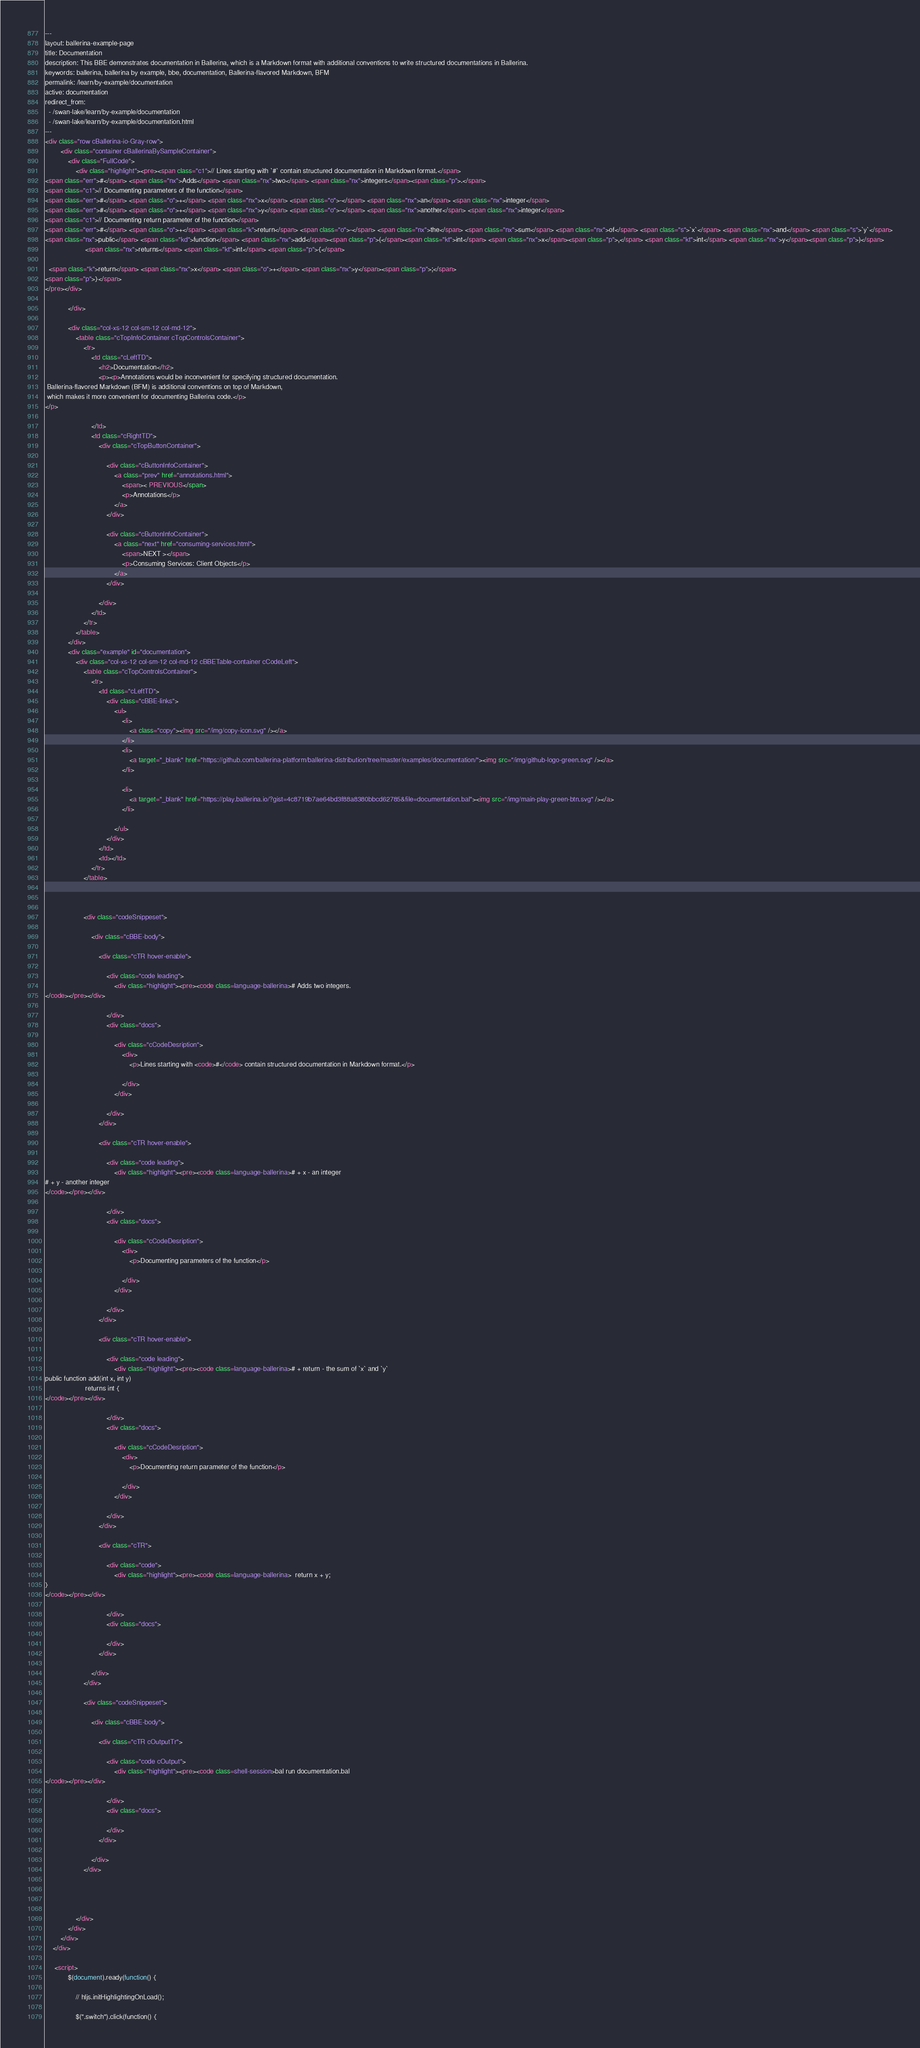Convert code to text. <code><loc_0><loc_0><loc_500><loc_500><_HTML_>---
layout: ballerina-example-page
title: Documentation
description: This BBE demonstrates documentation in Ballerina, which is a Markdown format with additional conventions to write structured documentations in Ballerina.
keywords: ballerina, ballerina by example, bbe, documentation, Ballerina-flavored Markdown, BFM
permalink: /learn/by-example/documentation
active: documentation
redirect_from:
  - /swan-lake/learn/by-example/documentation
  - /swan-lake/learn/by-example/documentation.html
---
<div class="row cBallerina-io-Gray-row">
        <div class="container cBallerinaBySampleContainer">
            <div class="FullCode">
                <div class="highlight"><pre><span class="c1">// Lines starting with `#` contain structured documentation in Markdown format.</span>
<span class="err">#</span> <span class="nx">Adds</span> <span class="nx">two</span> <span class="nx">integers</span><span class="p">.</span>
<span class="c1">// Documenting parameters of the function</span>
<span class="err">#</span> <span class="o">+</span> <span class="nx">x</span> <span class="o">-</span> <span class="nx">an</span> <span class="nx">integer</span>
<span class="err">#</span> <span class="o">+</span> <span class="nx">y</span> <span class="o">-</span> <span class="nx">another</span> <span class="nx">integer</span>
<span class="c1">// Documenting return parameter of the function</span>
<span class="err">#</span> <span class="o">+</span> <span class="k">return</span> <span class="o">-</span> <span class="nx">the</span> <span class="nx">sum</span> <span class="nx">of</span> <span class="s">`x`</span> <span class="nx">and</span> <span class="s">`y`</span>
<span class="nx">public</span> <span class="kd">function</span> <span class="nx">add</span><span class="p">(</span><span class="kt">int</span> <span class="nx">x</span><span class="p">,</span> <span class="kt">int</span> <span class="nx">y</span><span class="p">)</span>
                     <span class="nx">returns</span> <span class="kt">int</span> <span class="p">{</span>

  <span class="k">return</span> <span class="nx">x</span> <span class="o">+</span> <span class="nx">y</span><span class="p">;</span>
<span class="p">}</span>
</pre></div>

            </div>

            <div class="col-xs-12 col-sm-12 col-md-12">
                <table class="cTopInfoContainer cTopControlsContainer">
                    <tr>
                        <td class="cLeftTD">
                            <h2>Documentation</h2>
                            <p><p>Annotations would be inconvenient for specifying structured documentation.
 Ballerina-flavored Markdown (BFM) is additional conventions on top of Markdown,
 which makes it more convenient for documenting Ballerina code.</p>
</p>

                        </td>
                        <td class="cRightTD">
                            <div class="cTopButtonContainer">
                                
                                <div class="cButtonInfoContainer">
                                    <a class="prev" href="annotations.html">
                                        <span>< PREVIOUS</span>
                                        <p>Annotations</p>
                                    </a>
                                </div>
                                 
                                <div class="cButtonInfoContainer">
                                    <a class="next" href="consuming-services.html">
                                        <span>NEXT ></span>
                                        <p>Consuming Services: Client Objects</p>
                                    </a>
                                </div>
                                
                            </div>
                        </td>
                    </tr>
                </table>
            </div>
            <div class="example" id="documentation">
                <div class="col-xs-12 col-sm-12 col-md-12 cBBETable-container cCodeLeft">
                    <table class="cTopControlsContainer">
                        <tr>
                            <td class="cLeftTD">
                                <div class="cBBE-links">
                                    <ul>
                                        <li>
                                            <a class="copy"><img src="/img/copy-icon.svg" /></a>
                                        </li>
                                        <li>
                                            <a target="_blank" href="https://github.com/ballerina-platform/ballerina-distribution/tree/master/examples/documentation/"><img src="/img/github-logo-green.svg" /></a>
                                        </li>
                                        
                                        <li>
                                            <a target="_blank" href="https://play.ballerina.io/?gist=4c8719b7ae64bd3f88a8380bbcd62785&file=documentation.bal"><img src="/img/main-play-green-btn.svg" /></a>
                                        </li>
                                        
                                    </ul>
                                </div>
                            </td>
                            <td></td>
                        </tr>
                    </table>

              
                    
                    <div class="codeSnippeset">

                        <div class="cBBE-body">
                            
                            <div class="cTR hover-enable">

                                <div class="code leading">
                                    <div class="highlight"><pre><code class=language-ballerina># Adds two integers.
</code></pre></div>

                                </div>
                                <div class="docs">
                                    
                                    <div class="cCodeDesription">
                                        <div>
                                            <p>Lines starting with <code>#</code> contain structured documentation in Markdown format.</p>

                                        </div>
                                    </div>
                                    
                                </div>
                            </div>
                            
                            <div class="cTR hover-enable">

                                <div class="code leading">
                                    <div class="highlight"><pre><code class=language-ballerina># + x - an integer
# + y - another integer
</code></pre></div>

                                </div>
                                <div class="docs">
                                    
                                    <div class="cCodeDesription">
                                        <div>
                                            <p>Documenting parameters of the function</p>

                                        </div>
                                    </div>
                                    
                                </div>
                            </div>
                            
                            <div class="cTR hover-enable">

                                <div class="code leading">
                                    <div class="highlight"><pre><code class=language-ballerina># + return - the sum of `x` and `y`
public function add(int x, int y)
                     returns int {
</code></pre></div>

                                </div>
                                <div class="docs">
                                    
                                    <div class="cCodeDesription">
                                        <div>
                                            <p>Documenting return parameter of the function</p>

                                        </div>
                                    </div>
                                    
                                </div>
                            </div>
                            
                            <div class="cTR">

                                <div class="code">
                                    <div class="highlight"><pre><code class=language-ballerina>  return x + y;
}
</code></pre></div>

                                </div>
                                <div class="docs">
                                    
                                </div>
                            </div>
                            
                        </div>
                    </div>
                    
                    <div class="codeSnippeset">

                        <div class="cBBE-body">
                            
                            <div class="cTR cOutputTr">

                                <div class="code cOutput">
                                    <div class="highlight"><pre><code class=shell-session>bal run documentation.bal
</code></pre></div>

                                </div>
                                <div class="docs">
                                    
                                </div>
                            </div>
                            
                        </div>
                    </div>
                    


                     
                </div>
            </div>
        </div>
    </div>

     <script>
            $(document).ready(function() {

                // hljs.initHighlightingOnLoad();

                $(".switch").click(function() {</code> 